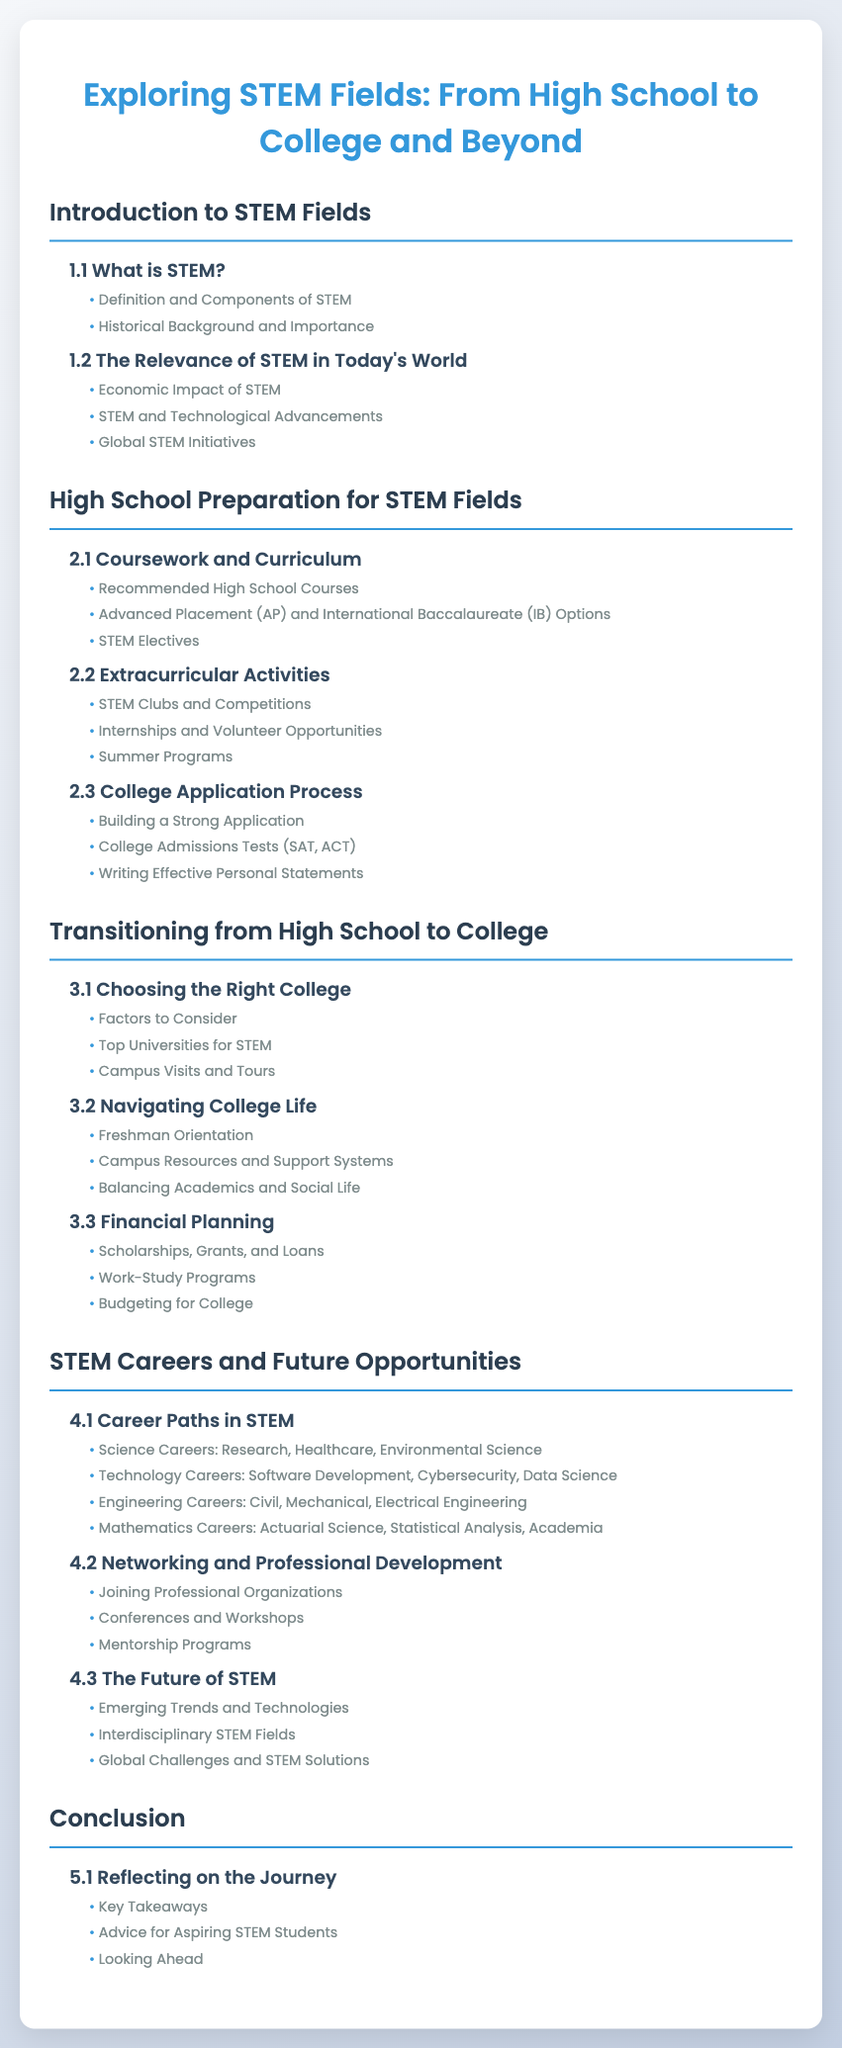What is the first section title in the Table of Contents? The first section title is the main topic of the document, which is "Introduction to STEM Fields."
Answer: Introduction to STEM Fields How many chapters are in the "High School Preparation for STEM Fields" section? This section includes a list of chapters, specifically three: Coursework and Curriculum, Extracurricular Activities, and College Application Process.
Answer: 3 What is the recommended high school subject that appears in the subheadings? Subheadings under "Coursework and Curriculum" mention "Recommended High School Courses."
Answer: Recommended High School Courses What is the first subheading under "Career Paths in STEM"? The first subheading in this chapter is related to one of the main areas within STEM careers.
Answer: Science Careers: Research, Healthcare, Environmental Science Name one aspect addressed in "Financial Planning." This section addresses important financial aspects for students transitioning to college, specifically scholarships, grants, and loans.
Answer: Scholarships, Grants, and Loans How many total sections are in the Table of Contents? The document outlines different segments of information, totaling five sections.
Answer: 5 What is a key topic discussed in the "Conclusion" section? The conclusion focuses on reflections and advice for students pursuing STEM paths.
Answer: Key Takeaways What type of activities are encouraged under "Extracurricular Activities"? The subheading highlights the importance of involvement beyond academics such as clubs and competitions.
Answer: STEM Clubs and Competitions 